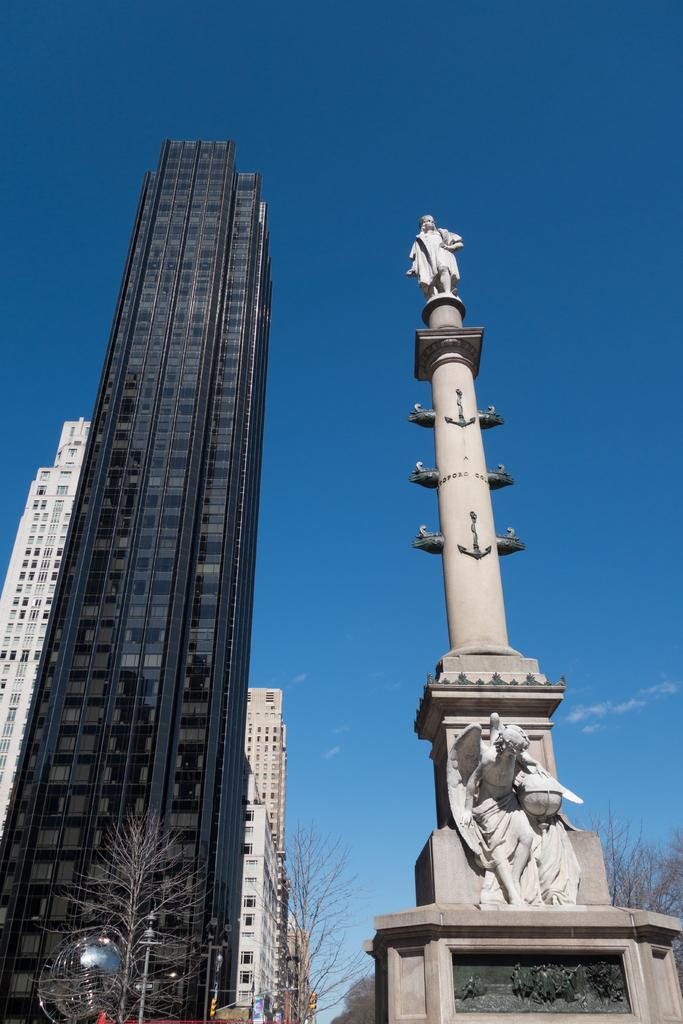What type of structures can be seen in the image? There are buildings in the image. What type of natural elements are present in the image? There are trees in the image. What type of artwork is present in the image? There is a statue in the image. What is visible in the background of the image? The sky is visible in the background of the image. Can you tell me how many islands are visible in the image? There are no islands present in the image. What type of magic is being performed by the statue in the image? There is no magic being performed by the statue in the image; it is a stationary artwork. 